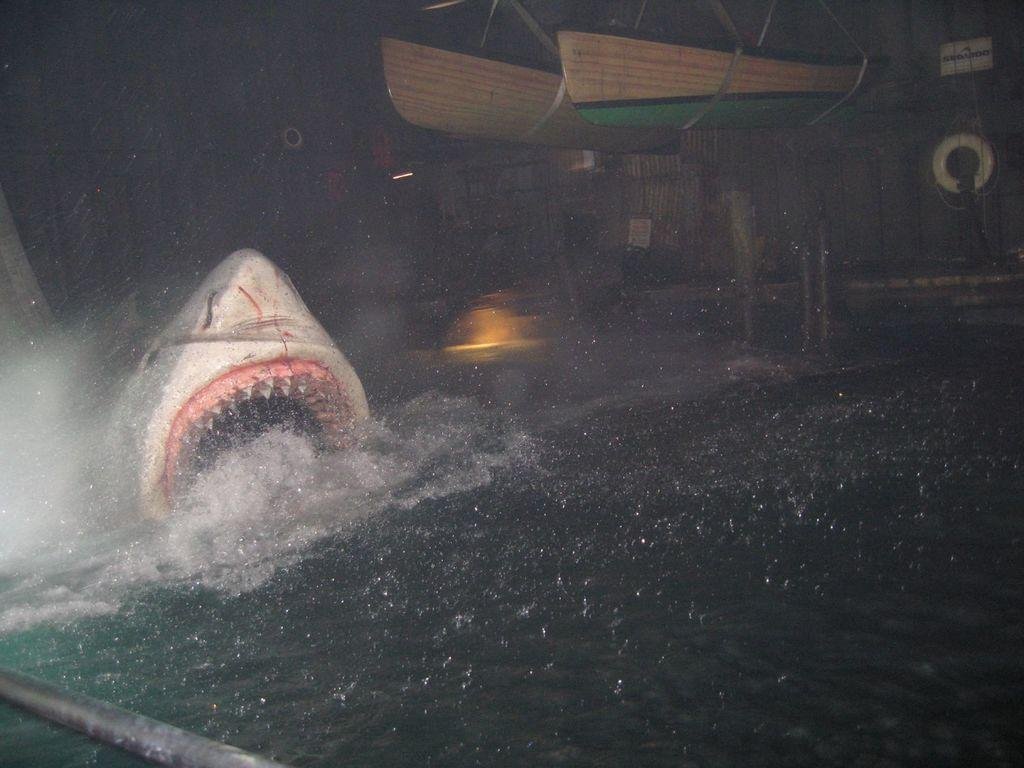What is the animal doing in the water? The animal is in the water, but the specific action cannot be determined from the facts provided. What else can be seen in the image besides the animal? There are boats in the image. What is located in the background of the image? There is an object that looks like a ship in the background. How many sheep are visible in the image? There are no sheep present in the image. What type of pencil can be seen being used by the animal in the image? There is no pencil present in the image, and the animal is not shown using any writing instrument. 